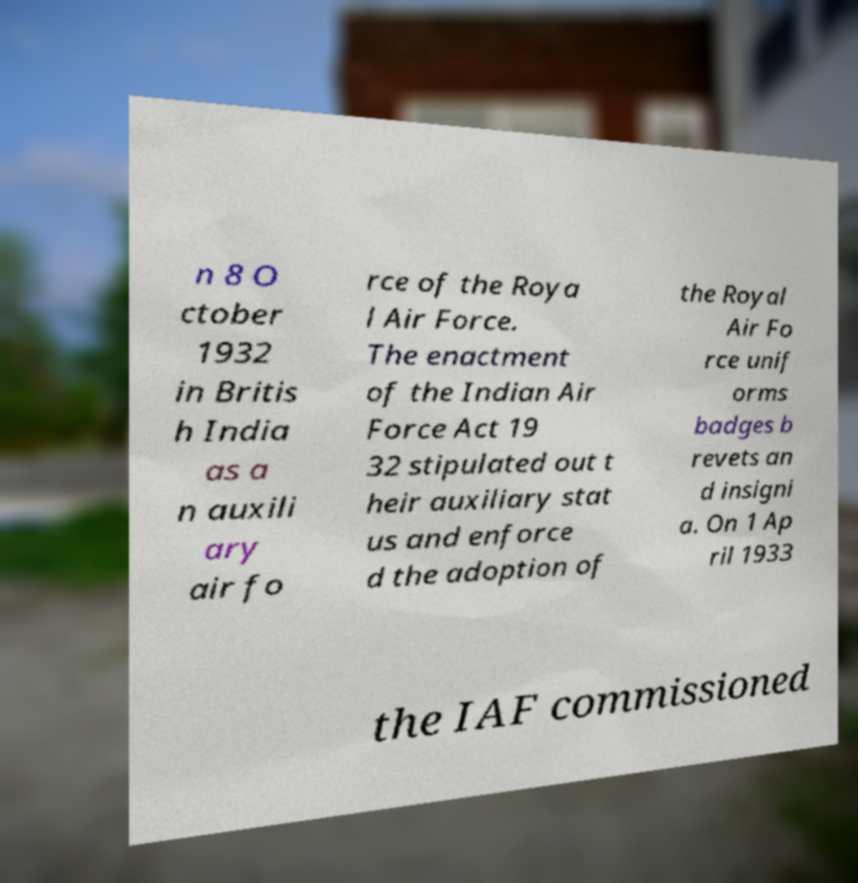Could you assist in decoding the text presented in this image and type it out clearly? n 8 O ctober 1932 in Britis h India as a n auxili ary air fo rce of the Roya l Air Force. The enactment of the Indian Air Force Act 19 32 stipulated out t heir auxiliary stat us and enforce d the adoption of the Royal Air Fo rce unif orms badges b revets an d insigni a. On 1 Ap ril 1933 the IAF commissioned 